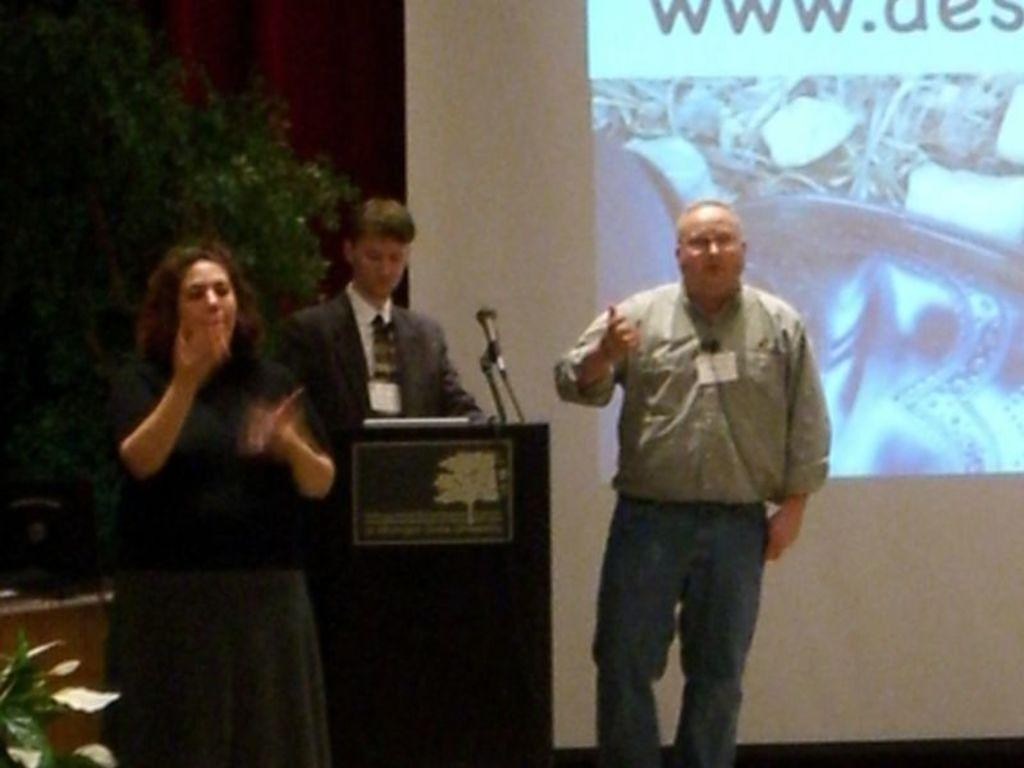How many people are on the stage in the image? There are two persons standing on the stage in the image. What is the person in front of the dais doing? The person standing in front of the dais is not visible in the image. What can be seen in the background of the image? There is a tree and a screen in the background of the image. What type of operation is being performed on the gold in the image? There is no operation or gold present in the image. 